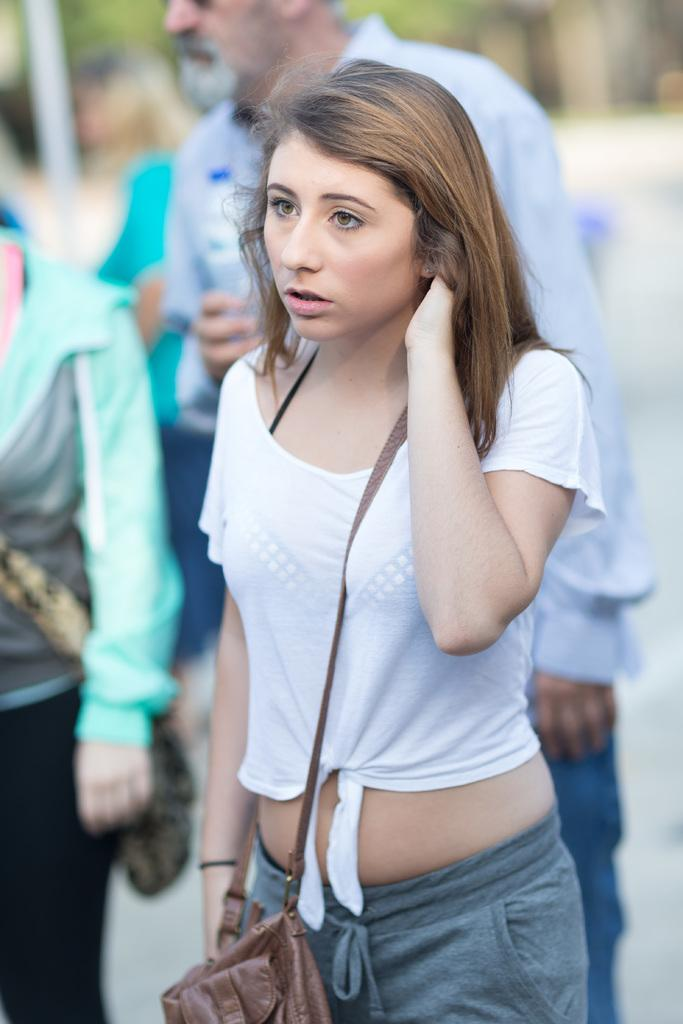Who is the main subject in the image? There is a woman in the image. What is the woman holding or carrying in the image? The woman is carrying a bag. Can you describe the background of the image? The background of the image is blurry. Are there any other people visible in the image? Yes, there are people visible in the background of the image. What is the woman's tendency to cross the boundary of her home in the image? There is no information about the woman's tendency or her home in the image. 